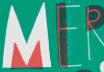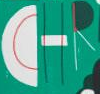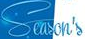Read the text from these images in sequence, separated by a semicolon. MER; CHR; Season's 